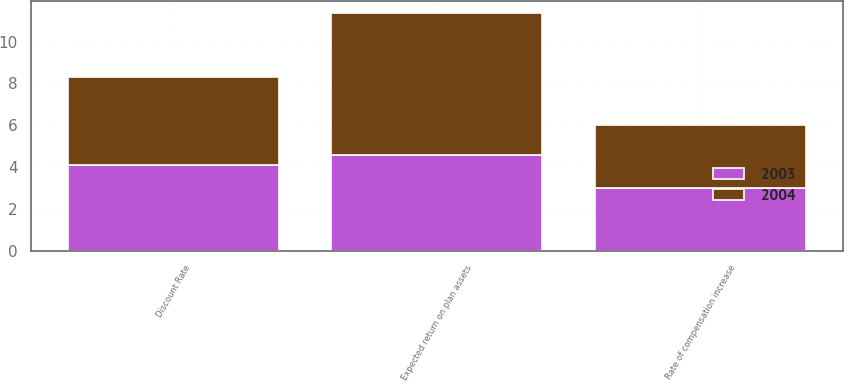<chart> <loc_0><loc_0><loc_500><loc_500><stacked_bar_chart><ecel><fcel>Discount Rate<fcel>Expected return on plan assets<fcel>Rate of compensation increase<nl><fcel>2003<fcel>4.07<fcel>4.59<fcel>2.97<nl><fcel>2004<fcel>4.24<fcel>6.77<fcel>3.05<nl></chart> 